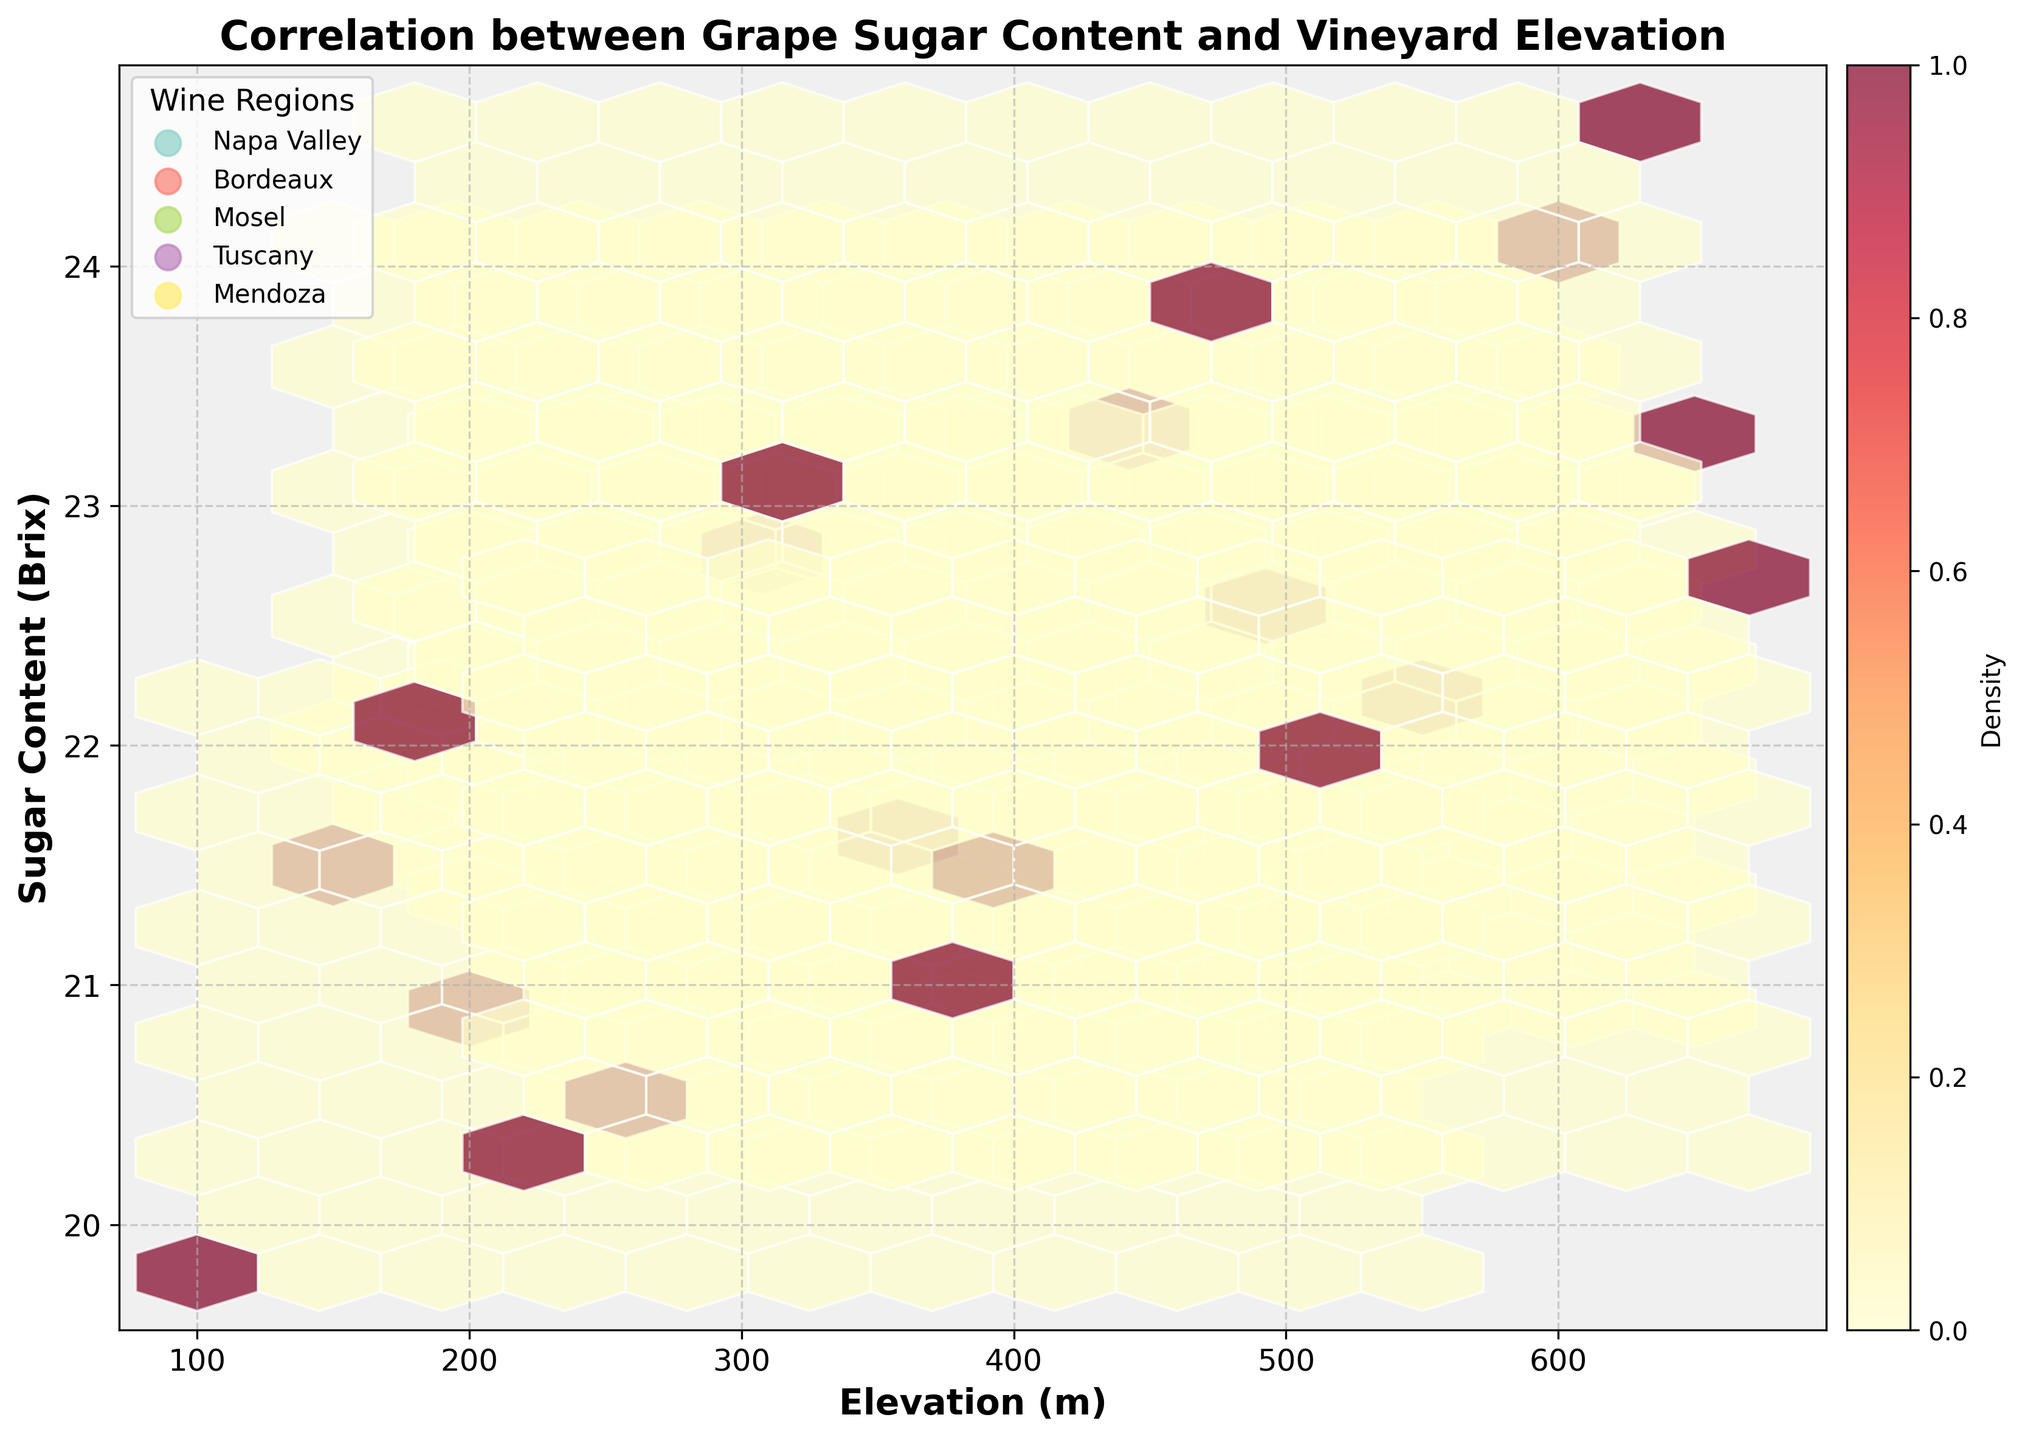What does the plot show about the relationship between grape sugar content and vineyard elevation? The plot shows a relationship between grape sugar content and vineyard elevation, with the title, "Correlation between Grape Sugar Content and Vineyard Elevation," indicating a positive correlation across multiple regions.
Answer: There is a positive correlation between grape sugar content and vineyard elevation What is the title of the figure? The title is prominently displayed at the top of the figure.
Answer: Correlation between Grape Sugar Content and Vineyard Elevation Which regions are included in the plot? The legend on the plot lists the wine regions represented by different colors.
Answer: Napa Valley, Bordeaux, Mosel, Tuscany, Mendoza What is the range of elevation displayed in the plot? The x-axis is labeled 'Elevation (m)' and ranges from the lowest to highest value shown.
Answer: 100 to 670 meters What does the color intensity represent in the hexbin plot? The color bar on the right side of the plot indicates that color intensity represents data density.
Answer: Data density Which wine region appears to have the highest grape sugar content at the highest elevations? By observing the plotted hexagons, Tuscany appears to have the highest grape sugar content at its highest elevations.
Answer: Tuscany Compare the sugar content for Napa Valley and Mosel at an elevation of around 400m. At an elevation of around 400m, Napa Valley has higher sugar content than Mosel.
Answer: Napa Valley has higher sugar content Does the hexbin plot show any regions with overlapping elevations but different sugar content? Yes, the plot shows hexagons with different densities and sugar content values for overlapping elevations, particularly between regions like Bordeaux and Mosel.
Answer: Yes What can you infer about Mendoza's elevation and sugar content compared to other regions? Mendoza's data points tend to show lower sugar content compared to Tuscany and Napa Valley at similar elevations.
Answer: Lower sugar content compared to Tuscany and Napa Valley at similar elevations How does the density of data points vary across different wine regions in the plot? By examining the hexbin colors, the density varies, with some regions having more concentrated areas of hexagons indicating higher data points, particularly Tuscany and Napa Valley.
Answer: The density of data points is highest in Tuscany and Napa Valley 